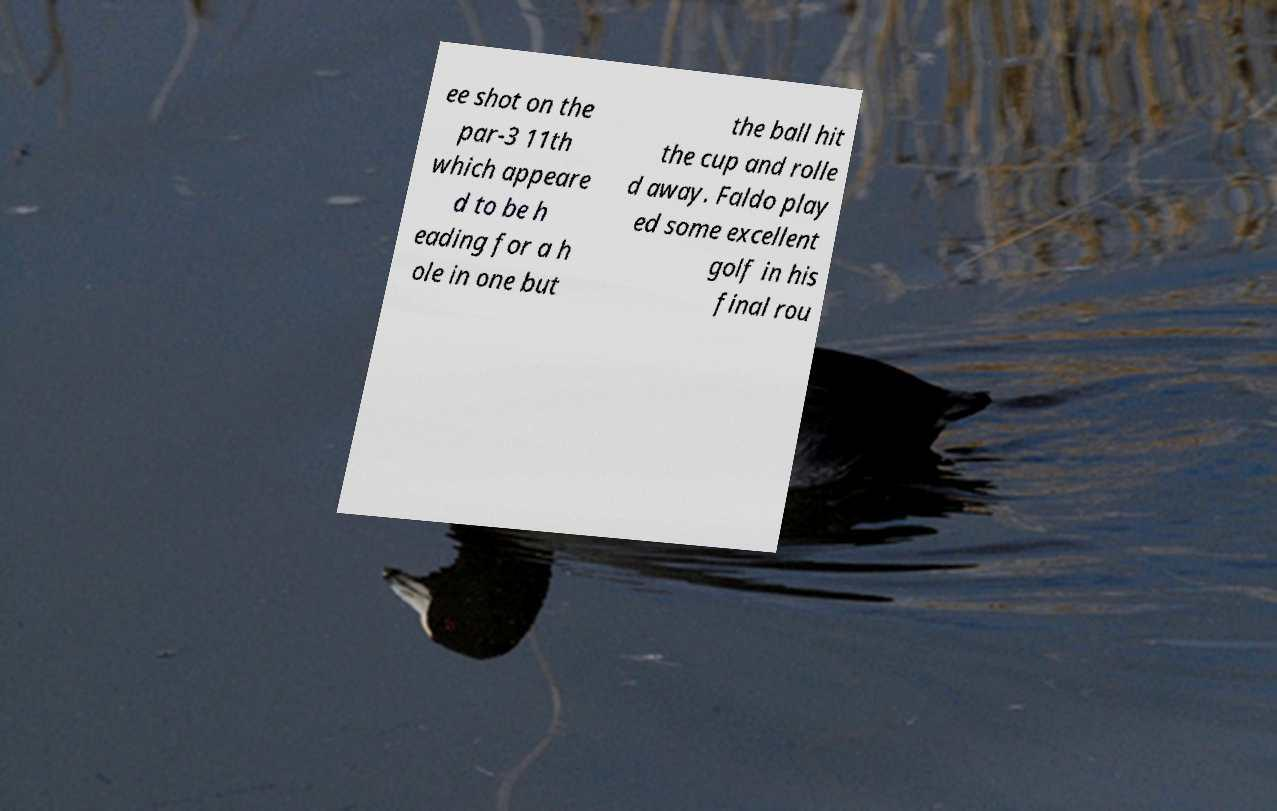There's text embedded in this image that I need extracted. Can you transcribe it verbatim? ee shot on the par-3 11th which appeare d to be h eading for a h ole in one but the ball hit the cup and rolle d away. Faldo play ed some excellent golf in his final rou 